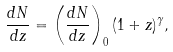Convert formula to latex. <formula><loc_0><loc_0><loc_500><loc_500>\frac { d N } { d z } = \left ( \frac { d N } { d z } \right ) _ { 0 } ( 1 + z ) ^ { \gamma } ,</formula> 